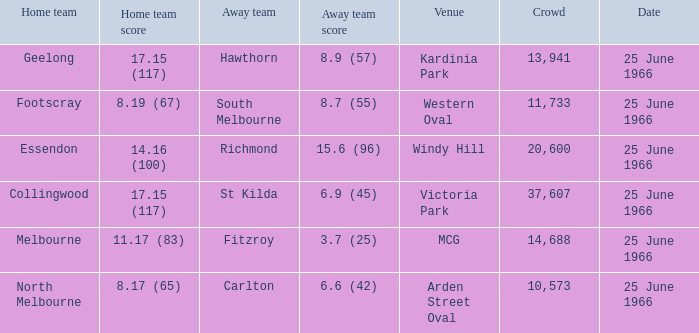What is the total crowd size when a home team scored 17.15 (117) versus hawthorn? 13941.0. Parse the table in full. {'header': ['Home team', 'Home team score', 'Away team', 'Away team score', 'Venue', 'Crowd', 'Date'], 'rows': [['Geelong', '17.15 (117)', 'Hawthorn', '8.9 (57)', 'Kardinia Park', '13,941', '25 June 1966'], ['Footscray', '8.19 (67)', 'South Melbourne', '8.7 (55)', 'Western Oval', '11,733', '25 June 1966'], ['Essendon', '14.16 (100)', 'Richmond', '15.6 (96)', 'Windy Hill', '20,600', '25 June 1966'], ['Collingwood', '17.15 (117)', 'St Kilda', '6.9 (45)', 'Victoria Park', '37,607', '25 June 1966'], ['Melbourne', '11.17 (83)', 'Fitzroy', '3.7 (25)', 'MCG', '14,688', '25 June 1966'], ['North Melbourne', '8.17 (65)', 'Carlton', '6.6 (42)', 'Arden Street Oval', '10,573', '25 June 1966']]} 